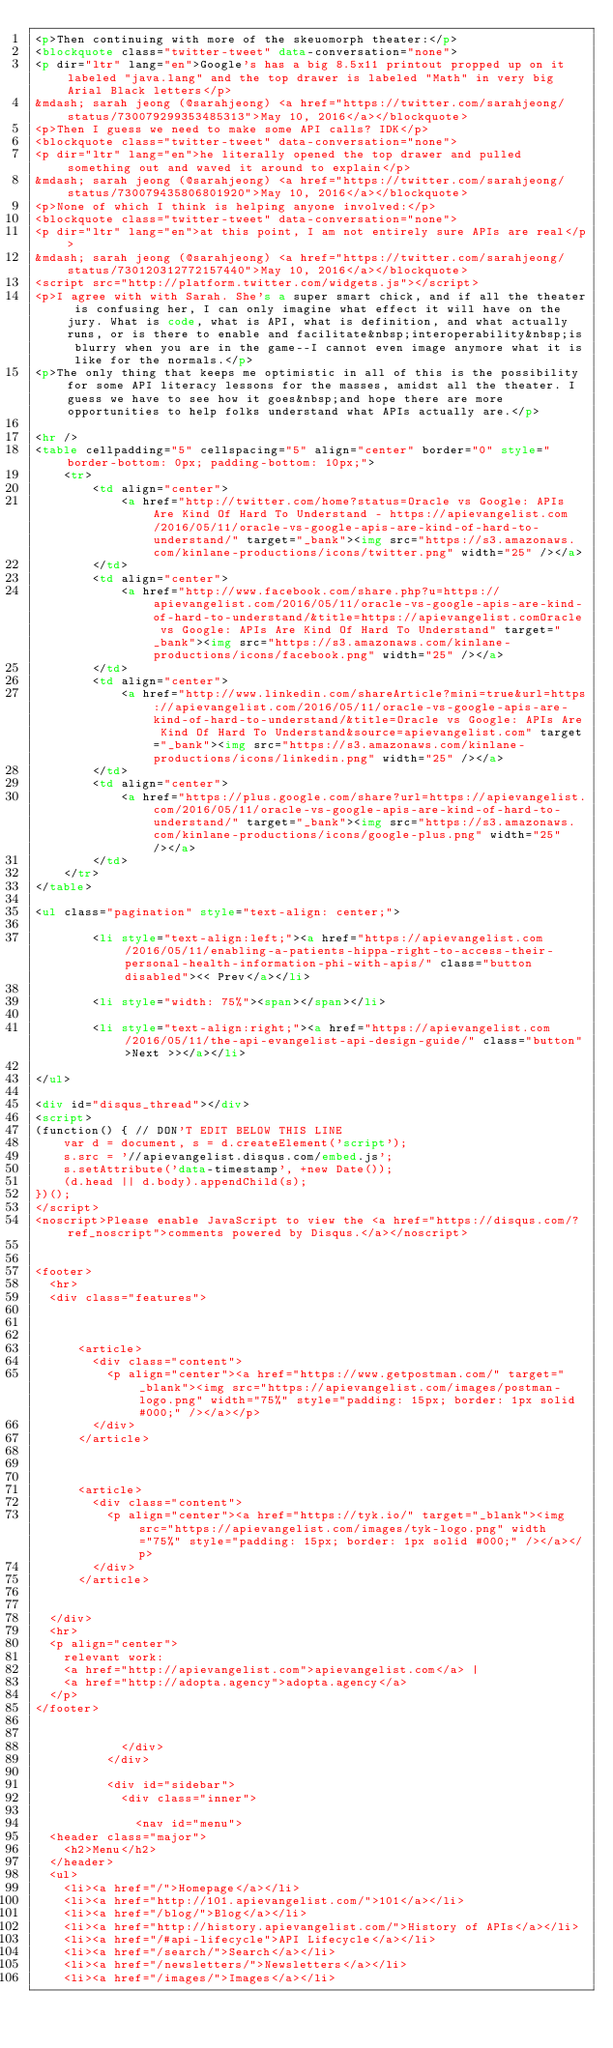<code> <loc_0><loc_0><loc_500><loc_500><_HTML_><p>Then continuing with more of the skeuomorph theater:</p>
<blockquote class="twitter-tweet" data-conversation="none">
<p dir="ltr" lang="en">Google's has a big 8.5x11 printout propped up on it labeled "java.lang" and the top drawer is labeled "Math" in very big Arial Black letters</p>
&mdash; sarah jeong (@sarahjeong) <a href="https://twitter.com/sarahjeong/status/730079299353485313">May 10, 2016</a></blockquote>
<p>Then I guess we need to make some API calls? IDK</p>
<blockquote class="twitter-tweet" data-conversation="none">
<p dir="ltr" lang="en">he literally opened the top drawer and pulled something out and waved it around to explain</p>
&mdash; sarah jeong (@sarahjeong) <a href="https://twitter.com/sarahjeong/status/730079435806801920">May 10, 2016</a></blockquote>
<p>None of which I think is helping anyone involved:</p>
<blockquote class="twitter-tweet" data-conversation="none">
<p dir="ltr" lang="en">at this point, I am not entirely sure APIs are real</p>
&mdash; sarah jeong (@sarahjeong) <a href="https://twitter.com/sarahjeong/status/730120312772157440">May 10, 2016</a></blockquote>
<script src="http://platform.twitter.com/widgets.js"></script>
<p>I agree with with Sarah. She's a super smart chick, and if all the theater is confusing her, I can only imagine what effect it will have on the jury. What is code, what is API, what is definition, and what actually runs, or is there to enable and facilitate&nbsp;interoperability&nbsp;is blurry when you are in the game--I cannot even image anymore what it is like for the normals.</p>
<p>The only thing that keeps me optimistic in all of this is the possibility for some API literacy lessons for the masses, amidst all the theater. I guess we have to see how it goes&nbsp;and hope there are more opportunities to help folks understand what APIs actually are.</p>

<hr />
<table cellpadding="5" cellspacing="5" align="center" border="0" style="border-bottom: 0px; padding-bottom: 10px;">
	<tr>
		<td align="center">
			<a href="http://twitter.com/home?status=Oracle vs Google: APIs Are Kind Of Hard To Understand - https://apievangelist.com/2016/05/11/oracle-vs-google-apis-are-kind-of-hard-to-understand/" target="_bank"><img src="https://s3.amazonaws.com/kinlane-productions/icons/twitter.png" width="25" /></a>
		</td>
		<td align="center">
			<a href="http://www.facebook.com/share.php?u=https://apievangelist.com/2016/05/11/oracle-vs-google-apis-are-kind-of-hard-to-understand/&title=https://apievangelist.comOracle vs Google: APIs Are Kind Of Hard To Understand" target="_bank"><img src="https://s3.amazonaws.com/kinlane-productions/icons/facebook.png" width="25" /></a>
		</td>
		<td align="center">
			<a href="http://www.linkedin.com/shareArticle?mini=true&url=https://apievangelist.com/2016/05/11/oracle-vs-google-apis-are-kind-of-hard-to-understand/&title=Oracle vs Google: APIs Are Kind Of Hard To Understand&source=apievangelist.com" target="_bank"><img src="https://s3.amazonaws.com/kinlane-productions/icons/linkedin.png" width="25" /></a>
		</td>
		<td align="center">
			<a href="https://plus.google.com/share?url=https://apievangelist.com/2016/05/11/oracle-vs-google-apis-are-kind-of-hard-to-understand/" target="_bank"><img src="https://s3.amazonaws.com/kinlane-productions/icons/google-plus.png" width="25" /></a>
		</td>
	</tr>
</table>

<ul class="pagination" style="text-align: center;">
	
		<li style="text-align:left;"><a href="https://apievangelist.com/2016/05/11/enabling-a-patients-hippa-right-to-access-their-personal-health-information-phi-with-apis/" class="button disabled"><< Prev</a></li>
	
		<li style="width: 75%"><span></span></li>
	
		<li style="text-align:right;"><a href="https://apievangelist.com/2016/05/11/the-api-evangelist-api-design-guide/" class="button">Next >></a></li>
	
</ul>

<div id="disqus_thread"></div>
<script>
(function() { // DON'T EDIT BELOW THIS LINE
    var d = document, s = d.createElement('script');
    s.src = '//apievangelist.disqus.com/embed.js';
    s.setAttribute('data-timestamp', +new Date());
    (d.head || d.body).appendChild(s);
})();
</script>
<noscript>Please enable JavaScript to view the <a href="https://disqus.com/?ref_noscript">comments powered by Disqus.</a></noscript>

              
<footer>
  <hr>
  <div class="features">
    
    
      
      <article>
        <div class="content">
          <p align="center"><a href="https://www.getpostman.com/" target="_blank"><img src="https://apievangelist.com/images/postman-logo.png" width="75%" style="padding: 15px; border: 1px solid #000;" /></a></p>
        </div>
      </article>
      
    
      
      <article>
        <div class="content">
          <p align="center"><a href="https://tyk.io/" target="_blank"><img src="https://apievangelist.com/images/tyk-logo.png" width="75%" style="padding: 15px; border: 1px solid #000;" /></a></p>
        </div>
      </article>
      
    
  </div>
  <hr>
  <p align="center">
    relevant work:
    <a href="http://apievangelist.com">apievangelist.com</a> |
    <a href="http://adopta.agency">adopta.agency</a>
  </p>
</footer>


            </div>
          </div>

          <div id="sidebar">
            <div class="inner">

              <nav id="menu">
  <header class="major">
    <h2>Menu</h2>
  </header>
  <ul>
    <li><a href="/">Homepage</a></li>
    <li><a href="http://101.apievangelist.com/">101</a></li>
    <li><a href="/blog/">Blog</a></li>
    <li><a href="http://history.apievangelist.com/">History of APIs</a></li>
    <li><a href="/#api-lifecycle">API Lifecycle</a></li>
    <li><a href="/search/">Search</a></li>
    <li><a href="/newsletters/">Newsletters</a></li>
    <li><a href="/images/">Images</a></li></code> 